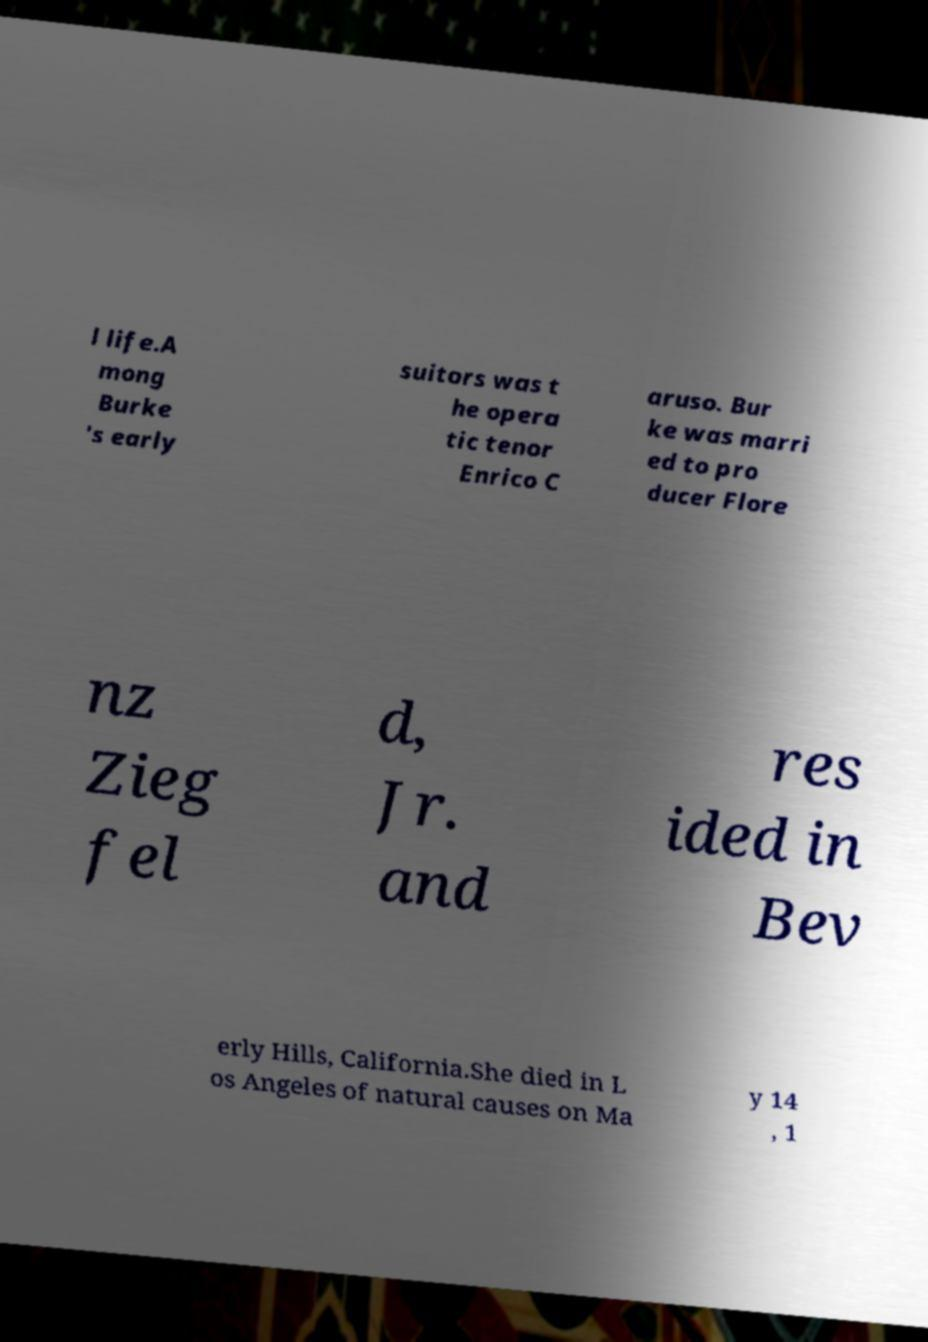Can you accurately transcribe the text from the provided image for me? l life.A mong Burke 's early suitors was t he opera tic tenor Enrico C aruso. Bur ke was marri ed to pro ducer Flore nz Zieg fel d, Jr. and res ided in Bev erly Hills, California.She died in L os Angeles of natural causes on Ma y 14 , 1 